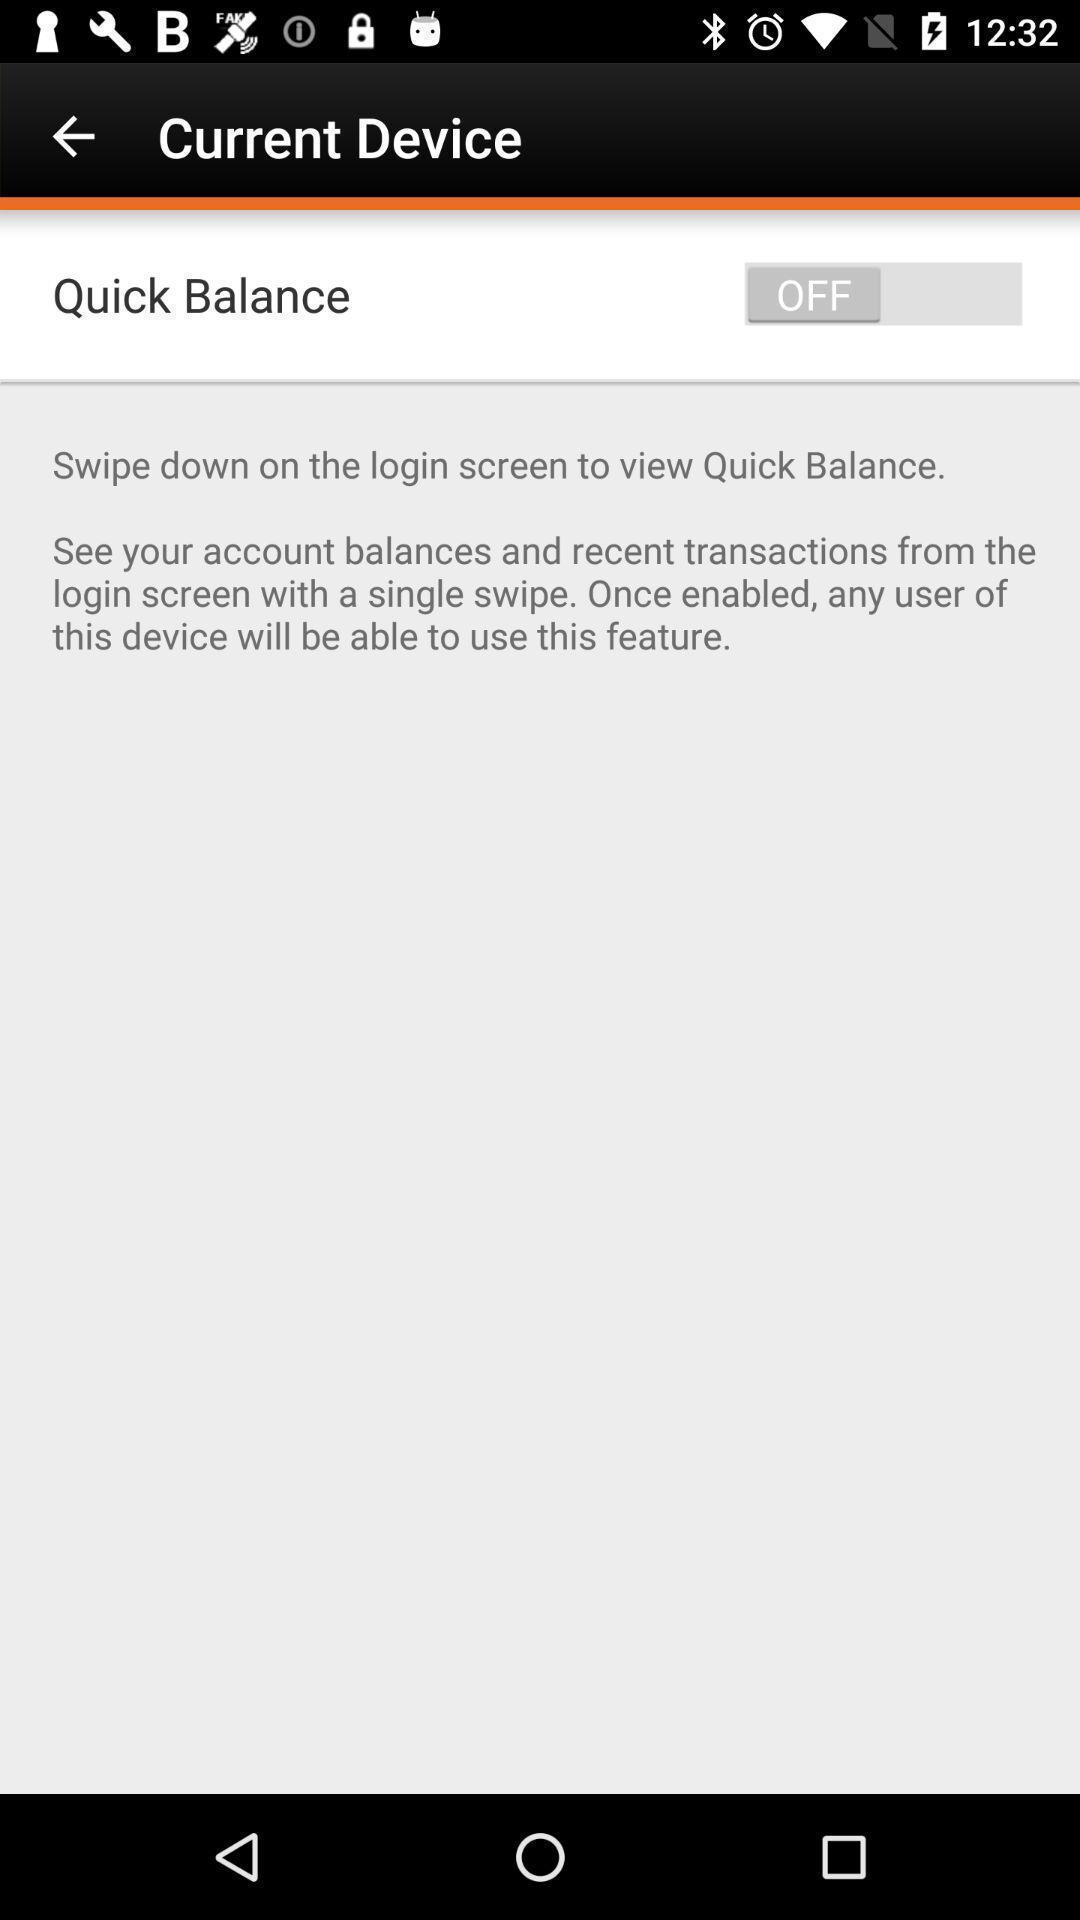Describe the key features of this screenshot. Screen displaying of financial application. 